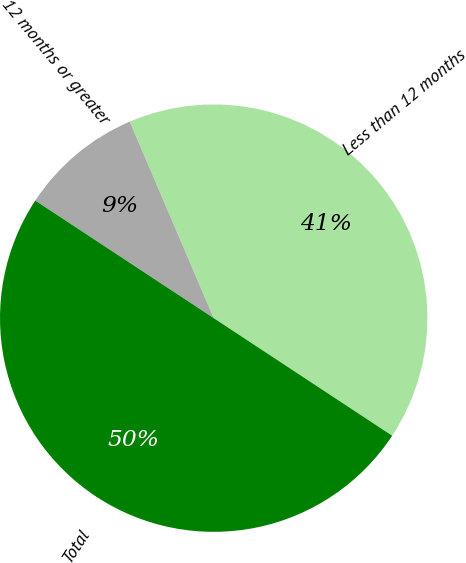Convert chart. <chart><loc_0><loc_0><loc_500><loc_500><pie_chart><fcel>Less than 12 months<fcel>12 months or greater<fcel>Total<nl><fcel>40.7%<fcel>9.3%<fcel>50.0%<nl></chart> 